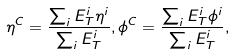Convert formula to latex. <formula><loc_0><loc_0><loc_500><loc_500>\eta ^ { C } = \frac { \sum _ { i } E _ { T } ^ { i } \eta ^ { i } } { \sum _ { i } E _ { T } ^ { i } } , \phi ^ { C } = \frac { \sum _ { i } E _ { T } ^ { i } \phi ^ { i } } { \sum _ { i } E _ { T } ^ { i } } ,</formula> 